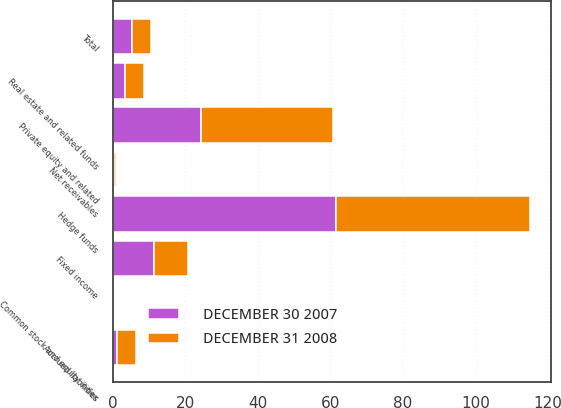<chart> <loc_0><loc_0><loc_500><loc_500><stacked_bar_chart><ecel><fcel>Private equity and related<fcel>Real estate and related funds<fcel>Common stock and equity index<fcel>Fixed income<fcel>Hedge funds<fcel>Net receivables<fcel>Accrued liabilities<fcel>Total<nl><fcel>DECEMBER 31 2008<fcel>36.2<fcel>5.3<fcel>0.2<fcel>9.4<fcel>53.6<fcel>0.6<fcel>5.3<fcel>5.3<nl><fcel>DECEMBER 30 2007<fcel>24.4<fcel>3.3<fcel>0.3<fcel>11.4<fcel>61.5<fcel>0.3<fcel>1.2<fcel>5.3<nl></chart> 